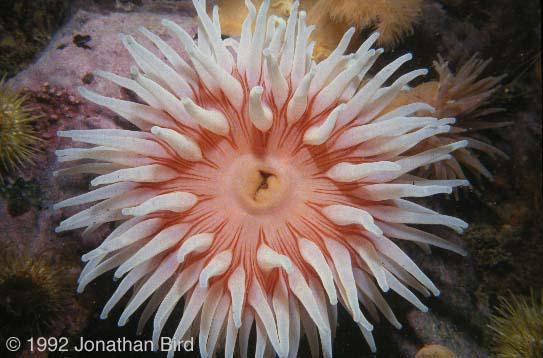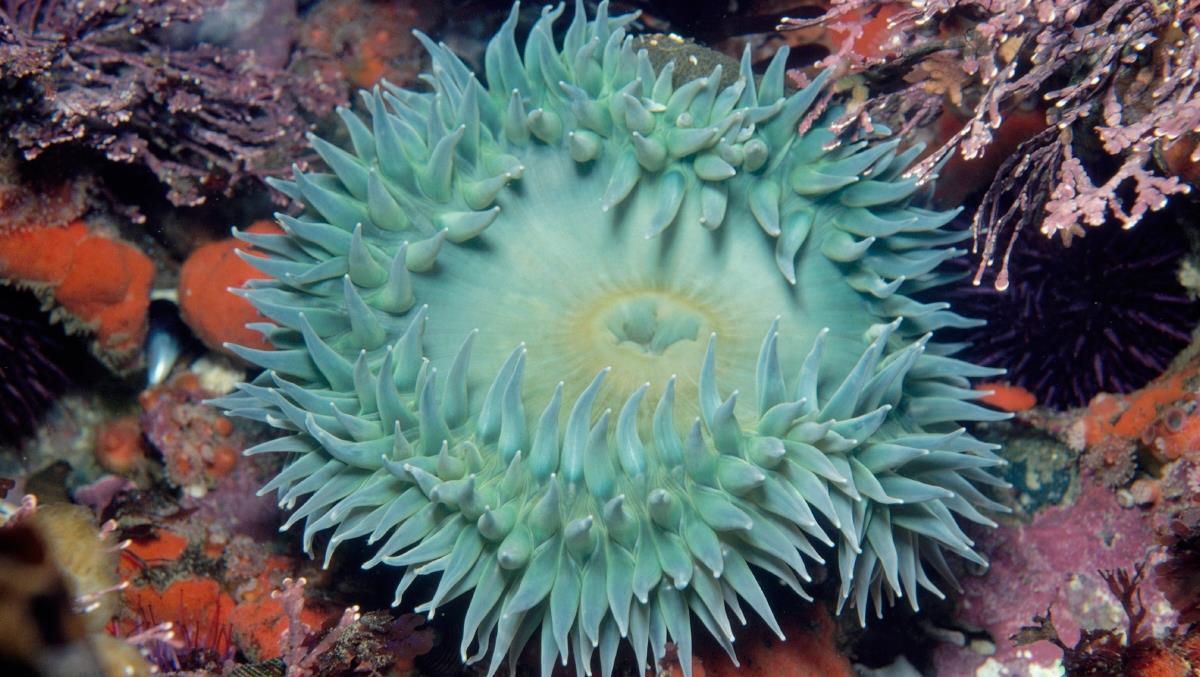The first image is the image on the left, the second image is the image on the right. Examine the images to the left and right. Is the description "Right and left images each show only one flower-shaped anemone with tendrils spreading out like petals, and the anemones do not share the same color." accurate? Answer yes or no. Yes. The first image is the image on the left, the second image is the image on the right. For the images shown, is this caption "There is a round anemone that is a pale peach color in the left image." true? Answer yes or no. Yes. 